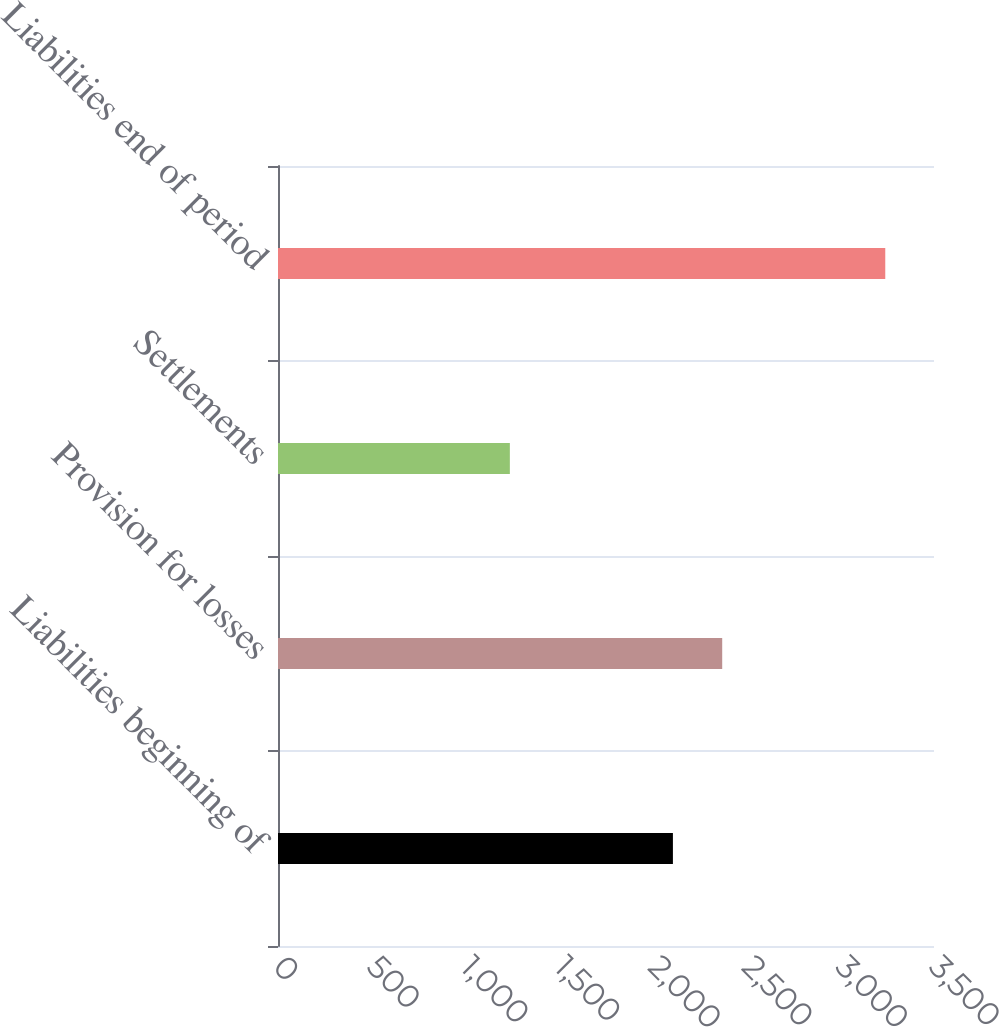Convert chart. <chart><loc_0><loc_0><loc_500><loc_500><bar_chart><fcel>Liabilities beginning of<fcel>Provision for losses<fcel>Settlements<fcel>Liabilities end of period<nl><fcel>2107<fcel>2370<fcel>1237<fcel>3240<nl></chart> 